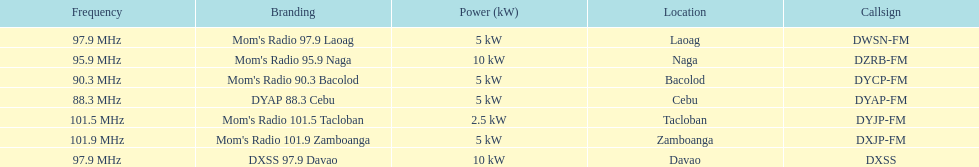How many stations broadcast with a power of 5kw? 4. 